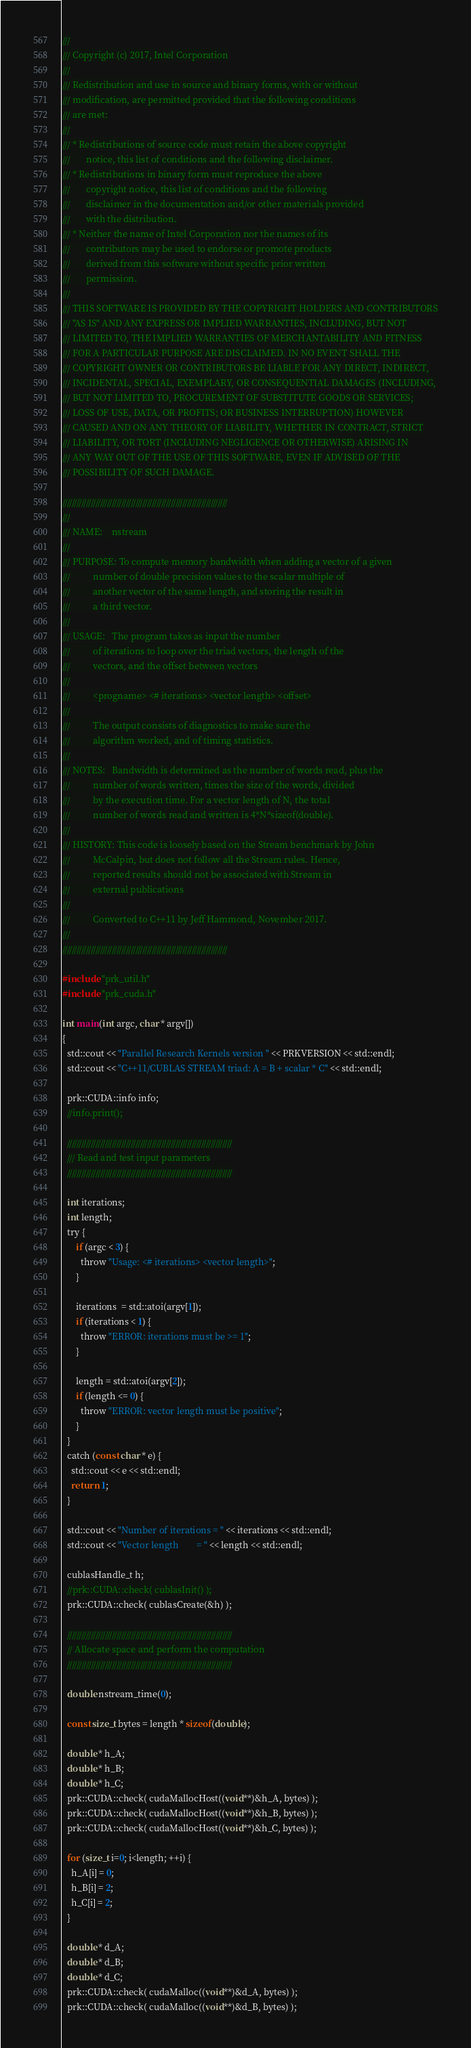Convert code to text. <code><loc_0><loc_0><loc_500><loc_500><_Cuda_>///
/// Copyright (c) 2017, Intel Corporation
///
/// Redistribution and use in source and binary forms, with or without
/// modification, are permitted provided that the following conditions
/// are met:
///
/// * Redistributions of source code must retain the above copyright
///       notice, this list of conditions and the following disclaimer.
/// * Redistributions in binary form must reproduce the above
///       copyright notice, this list of conditions and the following
///       disclaimer in the documentation and/or other materials provided
///       with the distribution.
/// * Neither the name of Intel Corporation nor the names of its
///       contributors may be used to endorse or promote products
///       derived from this software without specific prior written
///       permission.
///
/// THIS SOFTWARE IS PROVIDED BY THE COPYRIGHT HOLDERS AND CONTRIBUTORS
/// "AS IS" AND ANY EXPRESS OR IMPLIED WARRANTIES, INCLUDING, BUT NOT
/// LIMITED TO, THE IMPLIED WARRANTIES OF MERCHANTABILITY AND FITNESS
/// FOR A PARTICULAR PURPOSE ARE DISCLAIMED. IN NO EVENT SHALL THE
/// COPYRIGHT OWNER OR CONTRIBUTORS BE LIABLE FOR ANY DIRECT, INDIRECT,
/// INCIDENTAL, SPECIAL, EXEMPLARY, OR CONSEQUENTIAL DAMAGES (INCLUDING,
/// BUT NOT LIMITED TO, PROCUREMENT OF SUBSTITUTE GOODS OR SERVICES;
/// LOSS OF USE, DATA, OR PROFITS; OR BUSINESS INTERRUPTION) HOWEVER
/// CAUSED AND ON ANY THEORY OF LIABILITY, WHETHER IN CONTRACT, STRICT
/// LIABILITY, OR TORT (INCLUDING NEGLIGENCE OR OTHERWISE) ARISING IN
/// ANY WAY OUT OF THE USE OF THIS SOFTWARE, EVEN IF ADVISED OF THE
/// POSSIBILITY OF SUCH DAMAGE.

//////////////////////////////////////////////////////////////////////
///
/// NAME:    nstream
///
/// PURPOSE: To compute memory bandwidth when adding a vector of a given
///          number of double precision values to the scalar multiple of
///          another vector of the same length, and storing the result in
///          a third vector.
///
/// USAGE:   The program takes as input the number
///          of iterations to loop over the triad vectors, the length of the
///          vectors, and the offset between vectors
///
///          <progname> <# iterations> <vector length> <offset>
///
///          The output consists of diagnostics to make sure the
///          algorithm worked, and of timing statistics.
///
/// NOTES:   Bandwidth is determined as the number of words read, plus the
///          number of words written, times the size of the words, divided
///          by the execution time. For a vector length of N, the total
///          number of words read and written is 4*N*sizeof(double).
///
/// HISTORY: This code is loosely based on the Stream benchmark by John
///          McCalpin, but does not follow all the Stream rules. Hence,
///          reported results should not be associated with Stream in
///          external publications
///
///          Converted to C++11 by Jeff Hammond, November 2017.
///
//////////////////////////////////////////////////////////////////////

#include "prk_util.h"
#include "prk_cuda.h"

int main(int argc, char * argv[])
{
  std::cout << "Parallel Research Kernels version " << PRKVERSION << std::endl;
  std::cout << "C++11/CUBLAS STREAM triad: A = B + scalar * C" << std::endl;

  prk::CUDA::info info;
  //info.print();

  //////////////////////////////////////////////////////////////////////
  /// Read and test input parameters
  //////////////////////////////////////////////////////////////////////

  int iterations;
  int length;
  try {
      if (argc < 3) {
        throw "Usage: <# iterations> <vector length>";
      }

      iterations  = std::atoi(argv[1]);
      if (iterations < 1) {
        throw "ERROR: iterations must be >= 1";
      }

      length = std::atoi(argv[2]);
      if (length <= 0) {
        throw "ERROR: vector length must be positive";
      }
  }
  catch (const char * e) {
    std::cout << e << std::endl;
    return 1;
  }

  std::cout << "Number of iterations = " << iterations << std::endl;
  std::cout << "Vector length        = " << length << std::endl;

  cublasHandle_t h;
  //prk::CUDA::check( cublasInit() );
  prk::CUDA::check( cublasCreate(&h) );

  //////////////////////////////////////////////////////////////////////
  // Allocate space and perform the computation
  //////////////////////////////////////////////////////////////////////

  double nstream_time(0);

  const size_t bytes = length * sizeof(double);

  double * h_A;
  double * h_B;
  double * h_C;
  prk::CUDA::check( cudaMallocHost((void**)&h_A, bytes) );
  prk::CUDA::check( cudaMallocHost((void**)&h_B, bytes) );
  prk::CUDA::check( cudaMallocHost((void**)&h_C, bytes) );

  for (size_t i=0; i<length; ++i) {
    h_A[i] = 0;
    h_B[i] = 2;
    h_C[i] = 2;
  }

  double * d_A;
  double * d_B;
  double * d_C;
  prk::CUDA::check( cudaMalloc((void**)&d_A, bytes) );
  prk::CUDA::check( cudaMalloc((void**)&d_B, bytes) );</code> 